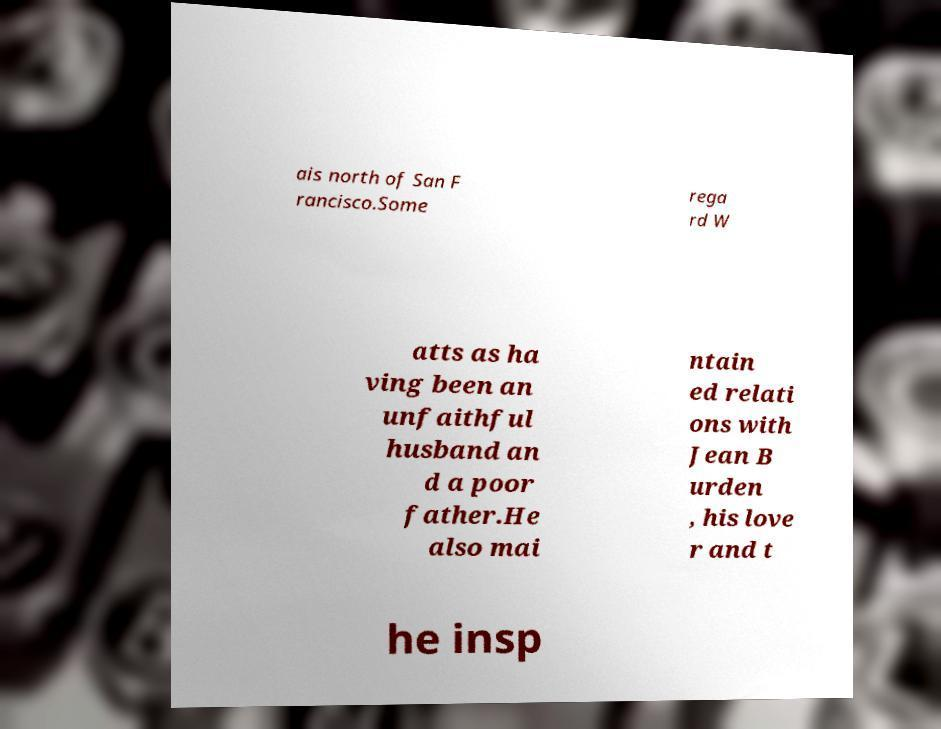Can you accurately transcribe the text from the provided image for me? ais north of San F rancisco.Some rega rd W atts as ha ving been an unfaithful husband an d a poor father.He also mai ntain ed relati ons with Jean B urden , his love r and t he insp 